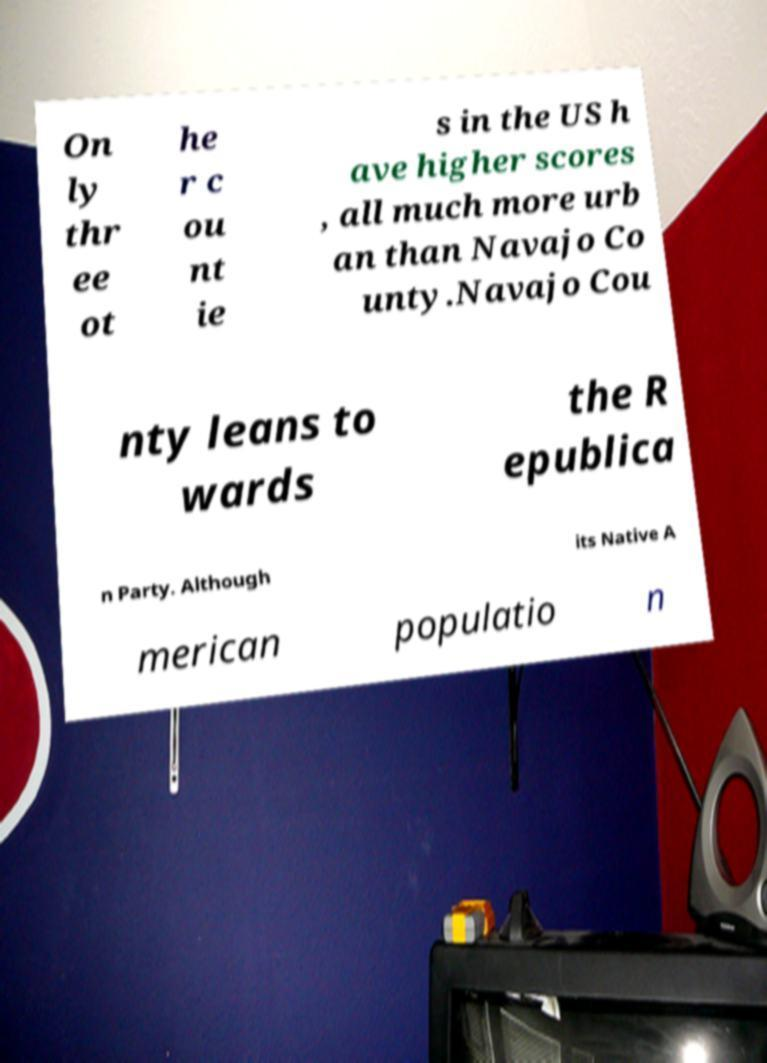Please read and relay the text visible in this image. What does it say? On ly thr ee ot he r c ou nt ie s in the US h ave higher scores , all much more urb an than Navajo Co unty.Navajo Cou nty leans to wards the R epublica n Party. Although its Native A merican populatio n 